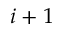<formula> <loc_0><loc_0><loc_500><loc_500>i + 1</formula> 